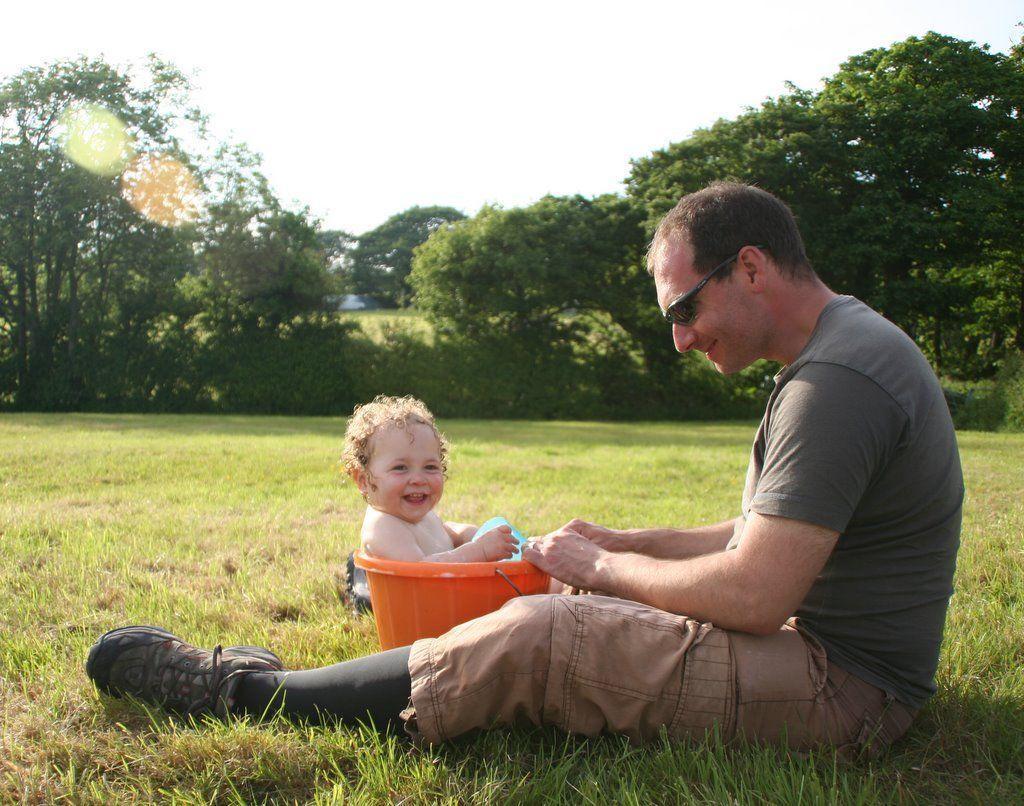Please provide a concise description of this image. This picture is clicked in a garden. There is a man sitting and he is wearing sunglasses. In front of him there is kid sitting in a bucket and he is smiling. There is grass on ground. In the background there are trees and sky. 